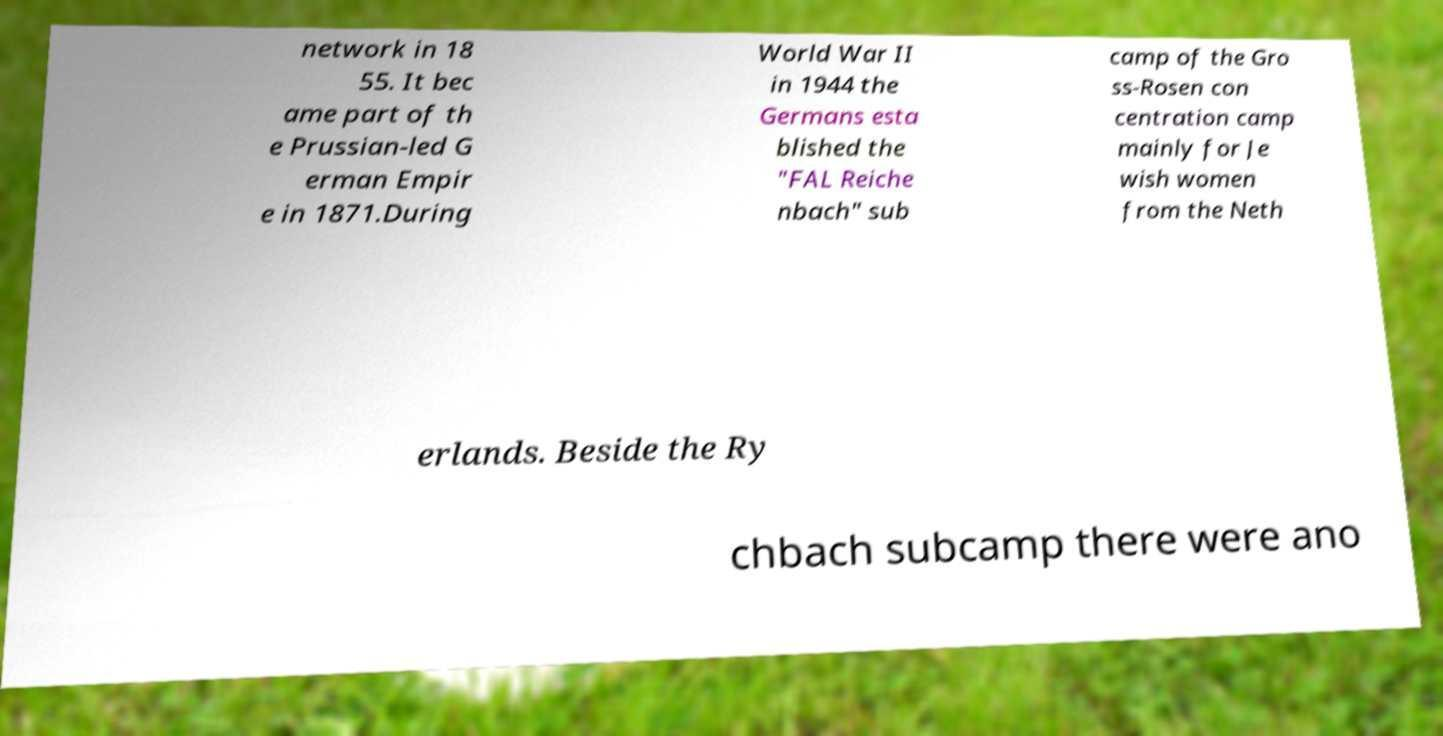For documentation purposes, I need the text within this image transcribed. Could you provide that? network in 18 55. It bec ame part of th e Prussian-led G erman Empir e in 1871.During World War II in 1944 the Germans esta blished the "FAL Reiche nbach" sub camp of the Gro ss-Rosen con centration camp mainly for Je wish women from the Neth erlands. Beside the Ry chbach subcamp there were ano 